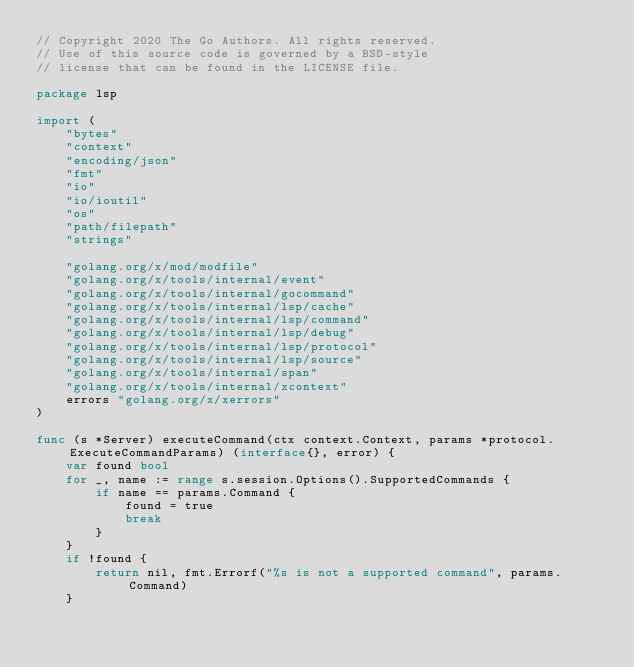Convert code to text. <code><loc_0><loc_0><loc_500><loc_500><_Go_>// Copyright 2020 The Go Authors. All rights reserved.
// Use of this source code is governed by a BSD-style
// license that can be found in the LICENSE file.

package lsp

import (
	"bytes"
	"context"
	"encoding/json"
	"fmt"
	"io"
	"io/ioutil"
	"os"
	"path/filepath"
	"strings"

	"golang.org/x/mod/modfile"
	"golang.org/x/tools/internal/event"
	"golang.org/x/tools/internal/gocommand"
	"golang.org/x/tools/internal/lsp/cache"
	"golang.org/x/tools/internal/lsp/command"
	"golang.org/x/tools/internal/lsp/debug"
	"golang.org/x/tools/internal/lsp/protocol"
	"golang.org/x/tools/internal/lsp/source"
	"golang.org/x/tools/internal/span"
	"golang.org/x/tools/internal/xcontext"
	errors "golang.org/x/xerrors"
)

func (s *Server) executeCommand(ctx context.Context, params *protocol.ExecuteCommandParams) (interface{}, error) {
	var found bool
	for _, name := range s.session.Options().SupportedCommands {
		if name == params.Command {
			found = true
			break
		}
	}
	if !found {
		return nil, fmt.Errorf("%s is not a supported command", params.Command)
	}
</code> 